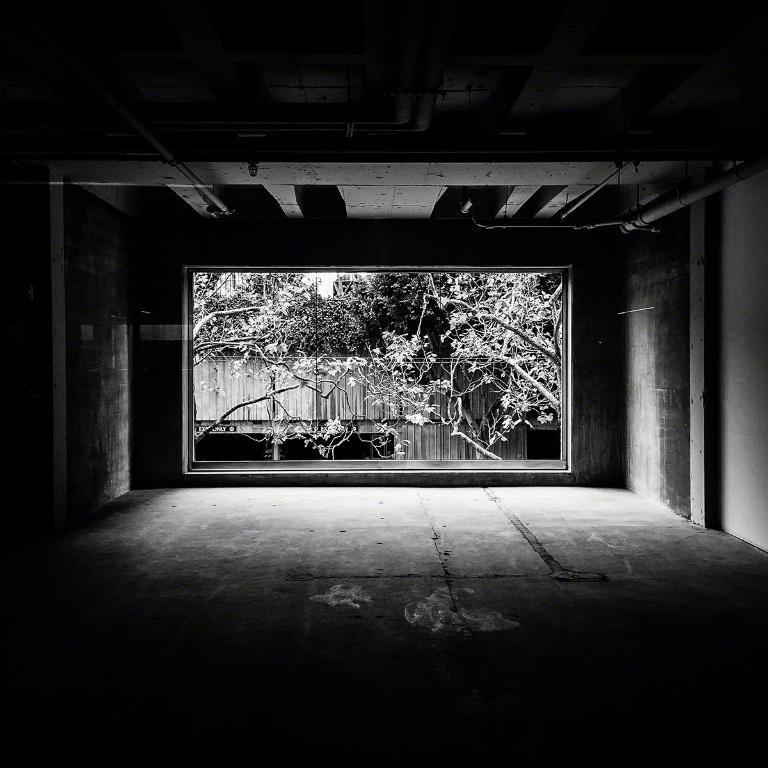How would you summarize this image in a sentence or two? It is a black and white image, in the middle there are trees. 